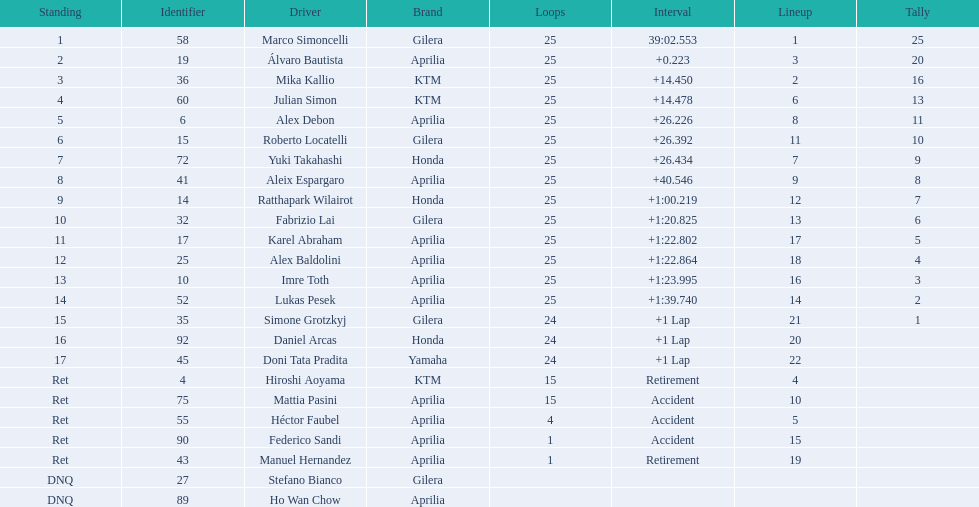What player number is marked #1 for the australian motorcycle grand prix? 58. Who is the rider that represents the #58 in the australian motorcycle grand prix? Marco Simoncelli. 